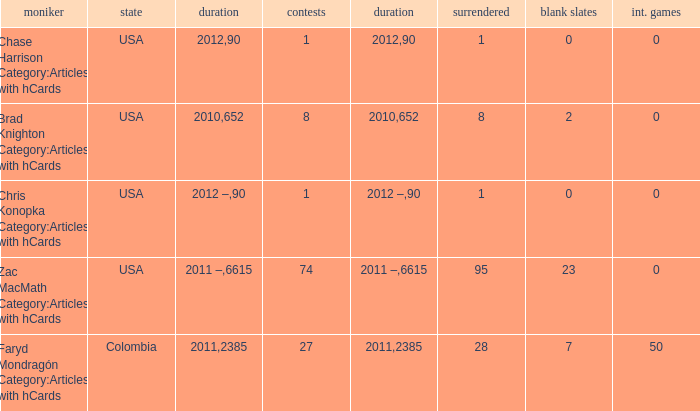When 2010 is the year what is the game? 8.0. 